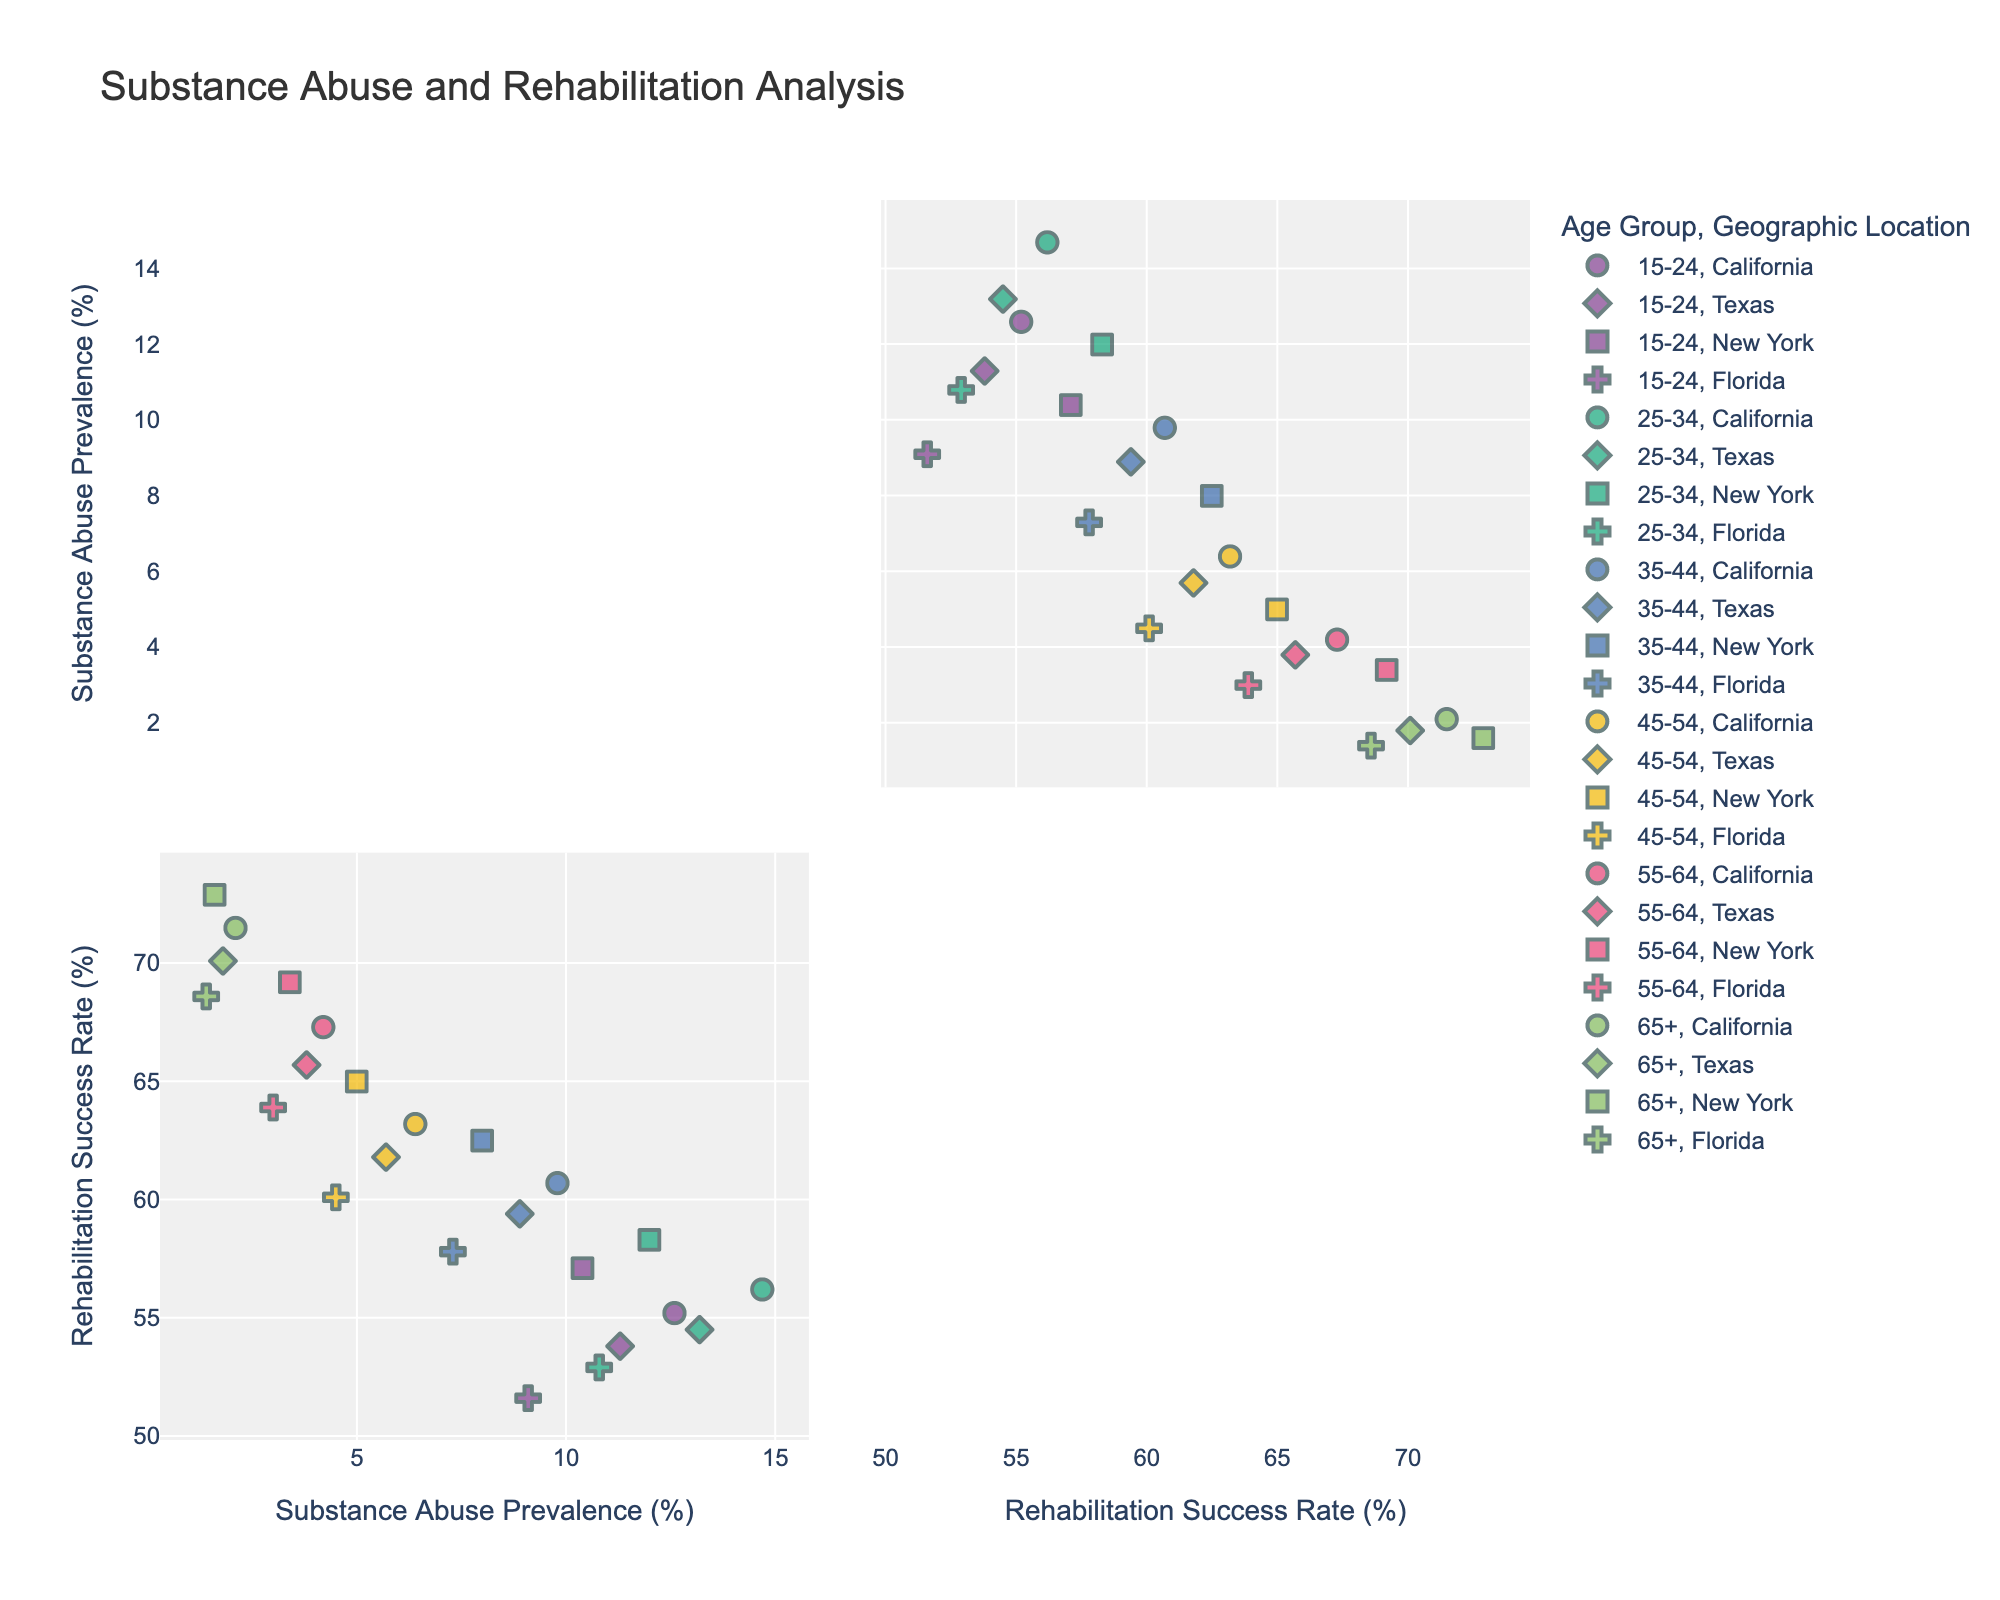What is the title of the figure? The title is written at the top of the figure. It should be clear and provide an overview of what the figure represents.
Answer: Substance Abuse and Rehabilitation Analysis What are the axis labels used in the figure? The axis labels are usually found along the x-axis and y-axis, and they describe what each axis represents.
Answer: Substance Abuse Prevalence (%) and Rehabilitation Success Rate (%) How many age groups are represented in the figure? You can determine the number of age groups by looking at the color legend in the figure. Each color represents a different age group.
Answer: 6 Which age group has the highest rehabilitation success rate? By looking at the highest points on the y-axis, notice the colors represented at those points, then check the legend for the corresponding age group.
Answer: 65+ How does the substance abuse prevalence in Texas for the 15-24 age group compare to California in the same age group? Locate the points representing Texas and California for the 15-24 age group on the x-axis, then compare their positions. The prevalence values can be directly read from the x-axis.
Answer: Texas: 11.3, California: 12.6; Texas is lower On average, which age group has the highest substance abuse prevalence? For each age group, you need to mentally summarise the substance abuse prevalence values and then identify which group has the highest average. This requires multiple comparisons across the x-axis.
Answer: 25-34 Which geographic location has the lowest rehabilitation success rate for the 35-44 age group? Identify the points marked by different symbols for the 35-44 age group, then find the one with the lowest y-axis value.
Answer: Florida Is there a general trend between age and substance abuse prevalence? Looking at the data points across different age groups, observe if there's an increasing or decreasing trend in the x-axis values with age.
Answer: Substance abuse prevalence decreases with age Comparing California and New York, which state has better overall rehabilitation success rates across all age groups? Observe the vertical positions (y-axis values) of the points from California and New York across different age groups. Whichever state has generally higher y-axis values is better.
Answer: New York For the 45-54 age group, what is the difference in rehabilitation success rates between Florida and Texas? Locate the points for the 45-54 age group in Florida and Texas on the y-axis, and then calculate the difference between those two values.
Answer: 60.1 - 61.8 = -1.7; Texas is 1.7 higher 